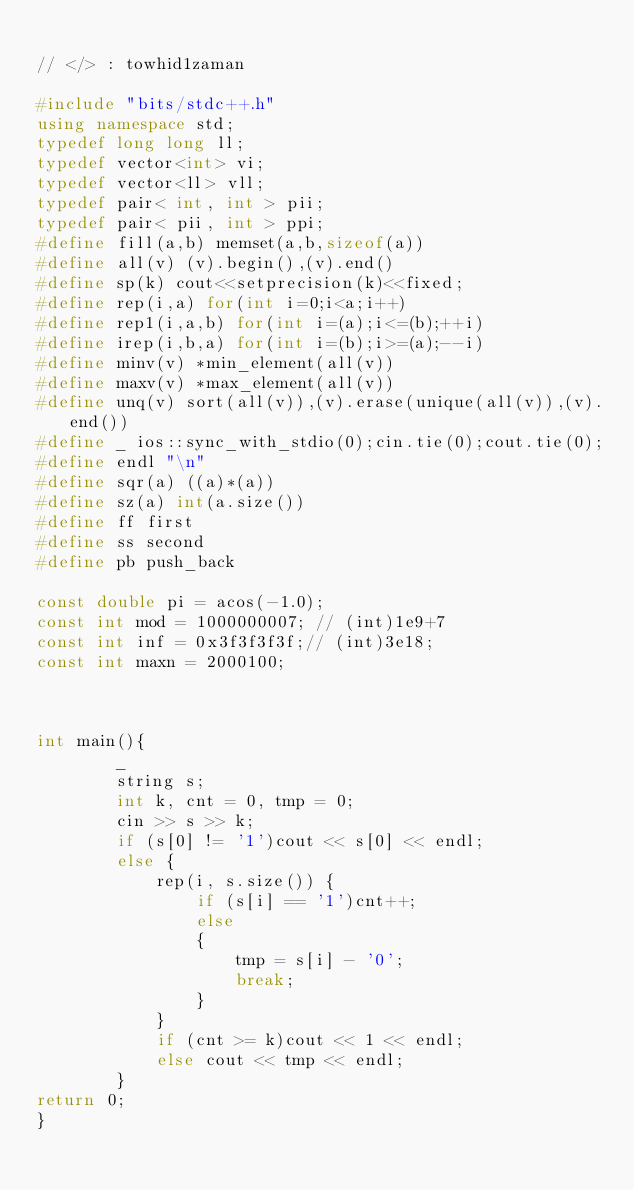Convert code to text. <code><loc_0><loc_0><loc_500><loc_500><_C++_>
// </> : towhid1zaman

#include "bits/stdc++.h"
using namespace std;
typedef long long ll;
typedef vector<int> vi;
typedef vector<ll> vll;
typedef pair< int, int > pii;
typedef pair< pii, int > ppi;
#define fill(a,b) memset(a,b,sizeof(a))
#define all(v) (v).begin(),(v).end()
#define sp(k) cout<<setprecision(k)<<fixed;
#define rep(i,a) for(int i=0;i<a;i++)
#define rep1(i,a,b) for(int i=(a);i<=(b);++i)
#define irep(i,b,a) for(int i=(b);i>=(a);--i)
#define minv(v) *min_element(all(v))
#define maxv(v) *max_element(all(v))
#define unq(v) sort(all(v)),(v).erase(unique(all(v)),(v).end())
#define _ ios::sync_with_stdio(0);cin.tie(0);cout.tie(0);
#define endl "\n"
#define sqr(a) ((a)*(a))
#define sz(a) int(a.size())
#define ff first
#define ss second
#define pb push_back

const double pi = acos(-1.0);
const int mod = 1000000007; // (int)1e9+7
const int inf = 0x3f3f3f3f;// (int)3e18;
const int maxn = 2000100;



int main(){
        _
        string s;
        int k, cnt = 0, tmp = 0;
        cin >> s >> k;
        if (s[0] != '1')cout << s[0] << endl;
        else {
            rep(i, s.size()) {
                if (s[i] == '1')cnt++;
                else
                {
                    tmp = s[i] - '0';
                    break;
                }
            }
            if (cnt >= k)cout << 1 << endl;
            else cout << tmp << endl;
        }
return 0;
}


</code> 